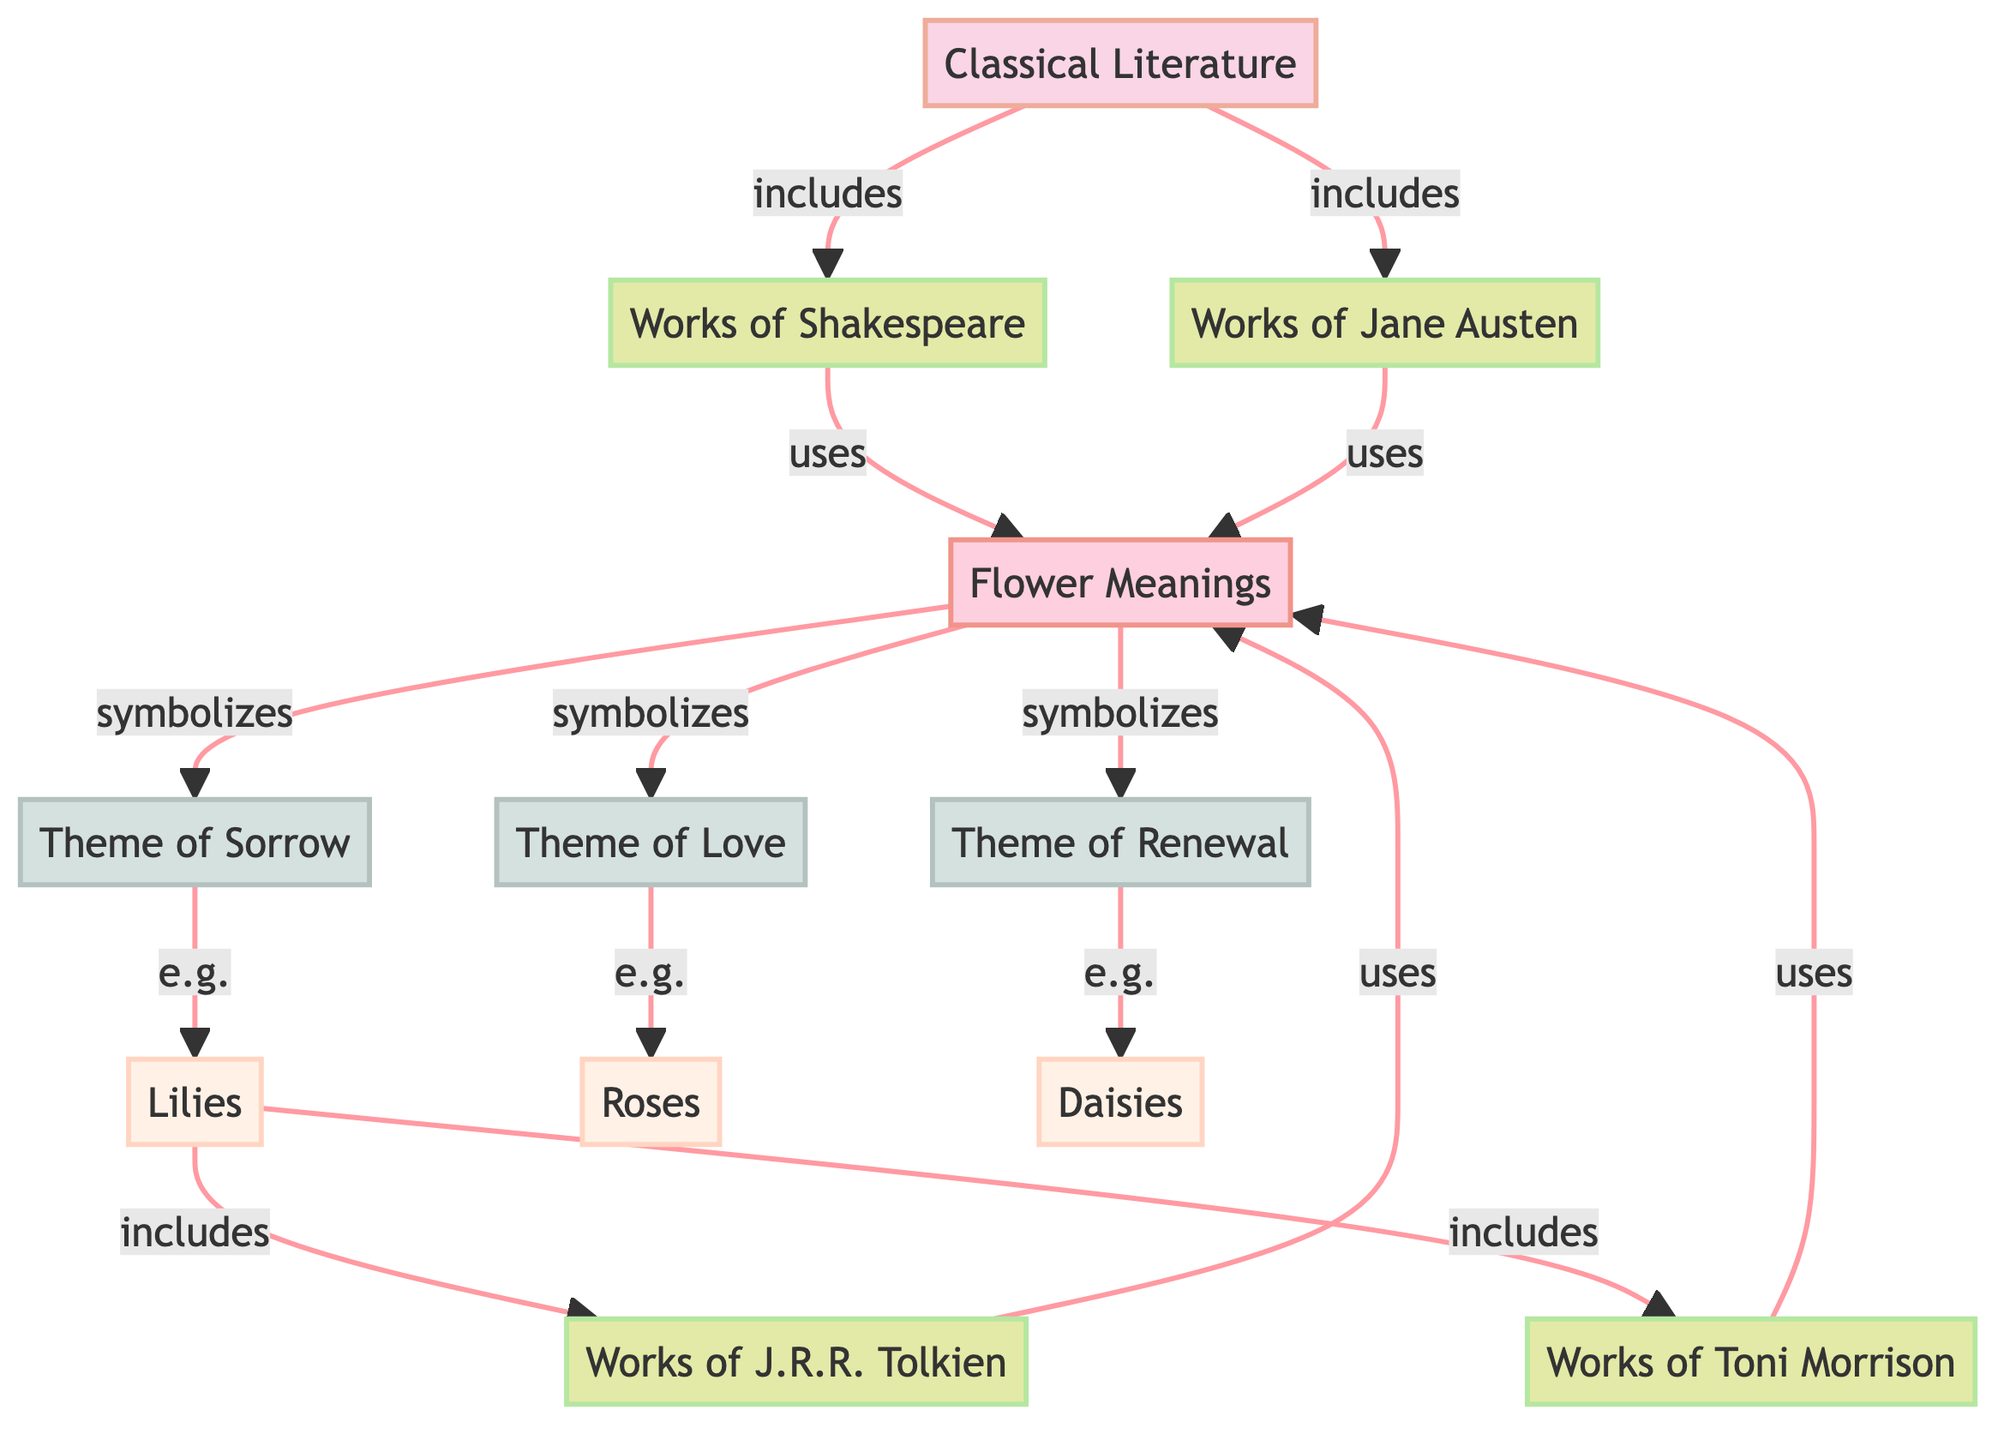What are the two categories of literature in the diagram? The diagram shows two main categories: Classical Literature and Modern Literature. These are the starting points for the analysis of floral metaphors.
Answer: Classical Literature, Modern Literature Which famous author's works are included in Modern Literature? The diagram specifies that J.R.R. Tolkien and Toni Morrison are works included under Modern Literature, highlighting their contributions to this category regarding floral metaphors.
Answer: J.R.R. Tolkien, Toni Morrison What theme is symbolized by roses? The diagram connects roses to the theme of love, indicating that in literature, roses are often used to express this theme.
Answer: Love How many themes are depicted in the diagram? The diagram illustrates three themes: love, sorrow, and renewal. Counting those themes gives us the total number depicted in the diagram.
Answer: 3 Which flower is used as an example for the theme of sorrow? The diagram indicates that lilies serve as the example flower connected to the theme of sorrow in literary contexts, demonstrating how different flowers convey various emotions.
Answer: Lilies Which flowers symbolize renewal according to the diagram? The diagram shows that daisies are linked to the theme of renewal, meaning that daisies represent concepts of new beginnings or rebirth in literature.
Answer: Daisies Which literature categories include Shakespeare's works? The diagram directs us from the Classical Literature node to works of Shakespeare, establishing that Shakespeare's contributions are part of the classical tradition in literature.
Answer: Classical Literature What are the connections between flower meanings and the themes? The diagram shows that flower meanings symbolize the themes of love, sorrow, and renewal, linking the broader understanding of flower symbolism in literature to specific emotional themes.
Answer: Symbolizes love, sorrow, renewal 